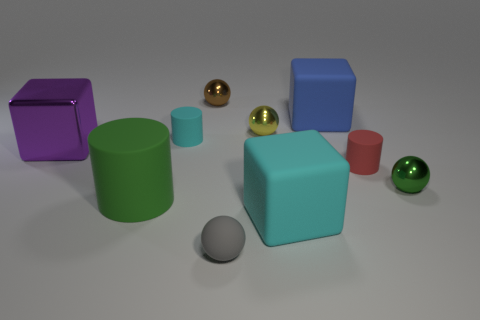Do the small object to the right of the red rubber thing and the tiny sphere behind the large blue object have the same material?
Make the answer very short. Yes. How many cyan matte things are the same shape as the tiny yellow object?
Provide a short and direct response. 0. There is a object that is the same color as the large rubber cylinder; what is its material?
Keep it short and to the point. Metal. How many things are purple balls or tiny balls that are to the right of the big blue matte block?
Provide a short and direct response. 1. What material is the brown object?
Keep it short and to the point. Metal. There is a tiny gray object that is the same shape as the small green shiny object; what is its material?
Make the answer very short. Rubber. There is a rubber object on the left side of the cyan matte object behind the red cylinder; what color is it?
Give a very brief answer. Green. What number of shiny objects are either gray balls or brown things?
Give a very brief answer. 1. Is the material of the large blue cube the same as the green sphere?
Your response must be concise. No. There is a cyan object behind the cyan matte block that is in front of the brown metallic sphere; what is its material?
Your answer should be very brief. Rubber. 